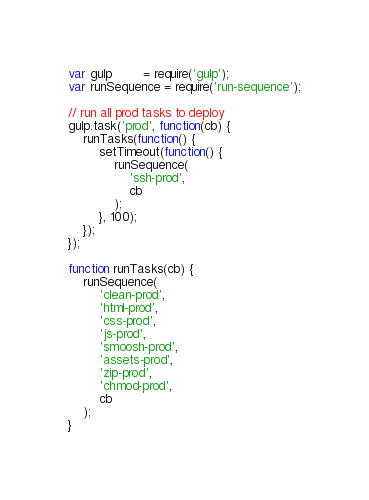<code> <loc_0><loc_0><loc_500><loc_500><_JavaScript_>var gulp        = require('gulp');
var runSequence = require('run-sequence');

// run all prod tasks to deploy
gulp.task('prod', function(cb) {
	runTasks(function() {
		setTimeout(function() {
			runSequence(
				'ssh-prod',
				cb
			);
		}, 100);
	});
});

function runTasks(cb) {
	runSequence(
		'clean-prod',
		'html-prod',
		'css-prod',
		'js-prod',
		'smoosh-prod',
		'assets-prod',
		'zip-prod',
		'chmod-prod',
		cb
	);
}
</code> 